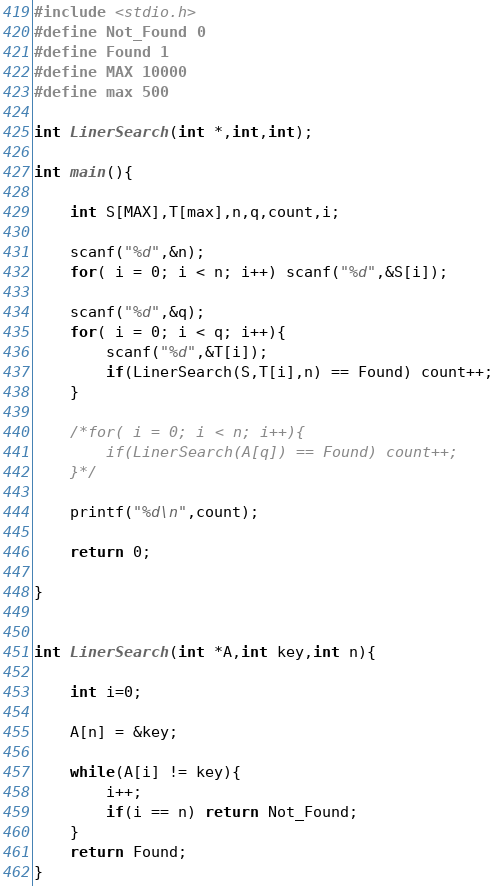<code> <loc_0><loc_0><loc_500><loc_500><_C_>#include <stdio.h>
#define Not_Found 0
#define Found 1
#define MAX 10000
#define max 500

int LinerSearch(int *,int,int);

int main(){

	int S[MAX],T[max],n,q,count,i;

	scanf("%d",&n);
	for( i = 0; i < n; i++) scanf("%d",&S[i]);
	
	scanf("%d",&q);
	for( i = 0; i < q; i++){
		scanf("%d",&T[i]);
		if(LinerSearch(S,T[i],n) == Found) count++;
	}

	/*for( i = 0; i < n; i++){
		if(LinerSearch(A[q]) == Found) count++;
	}*/

	printf("%d\n",count);

	return 0;

}


int LinerSearch(int *A,int key,int n){

	int i=0;

	A[n] = &key;

	while(A[i] != key){
		i++;
		if(i == n) return Not_Found;
	}
	return Found;
}</code> 